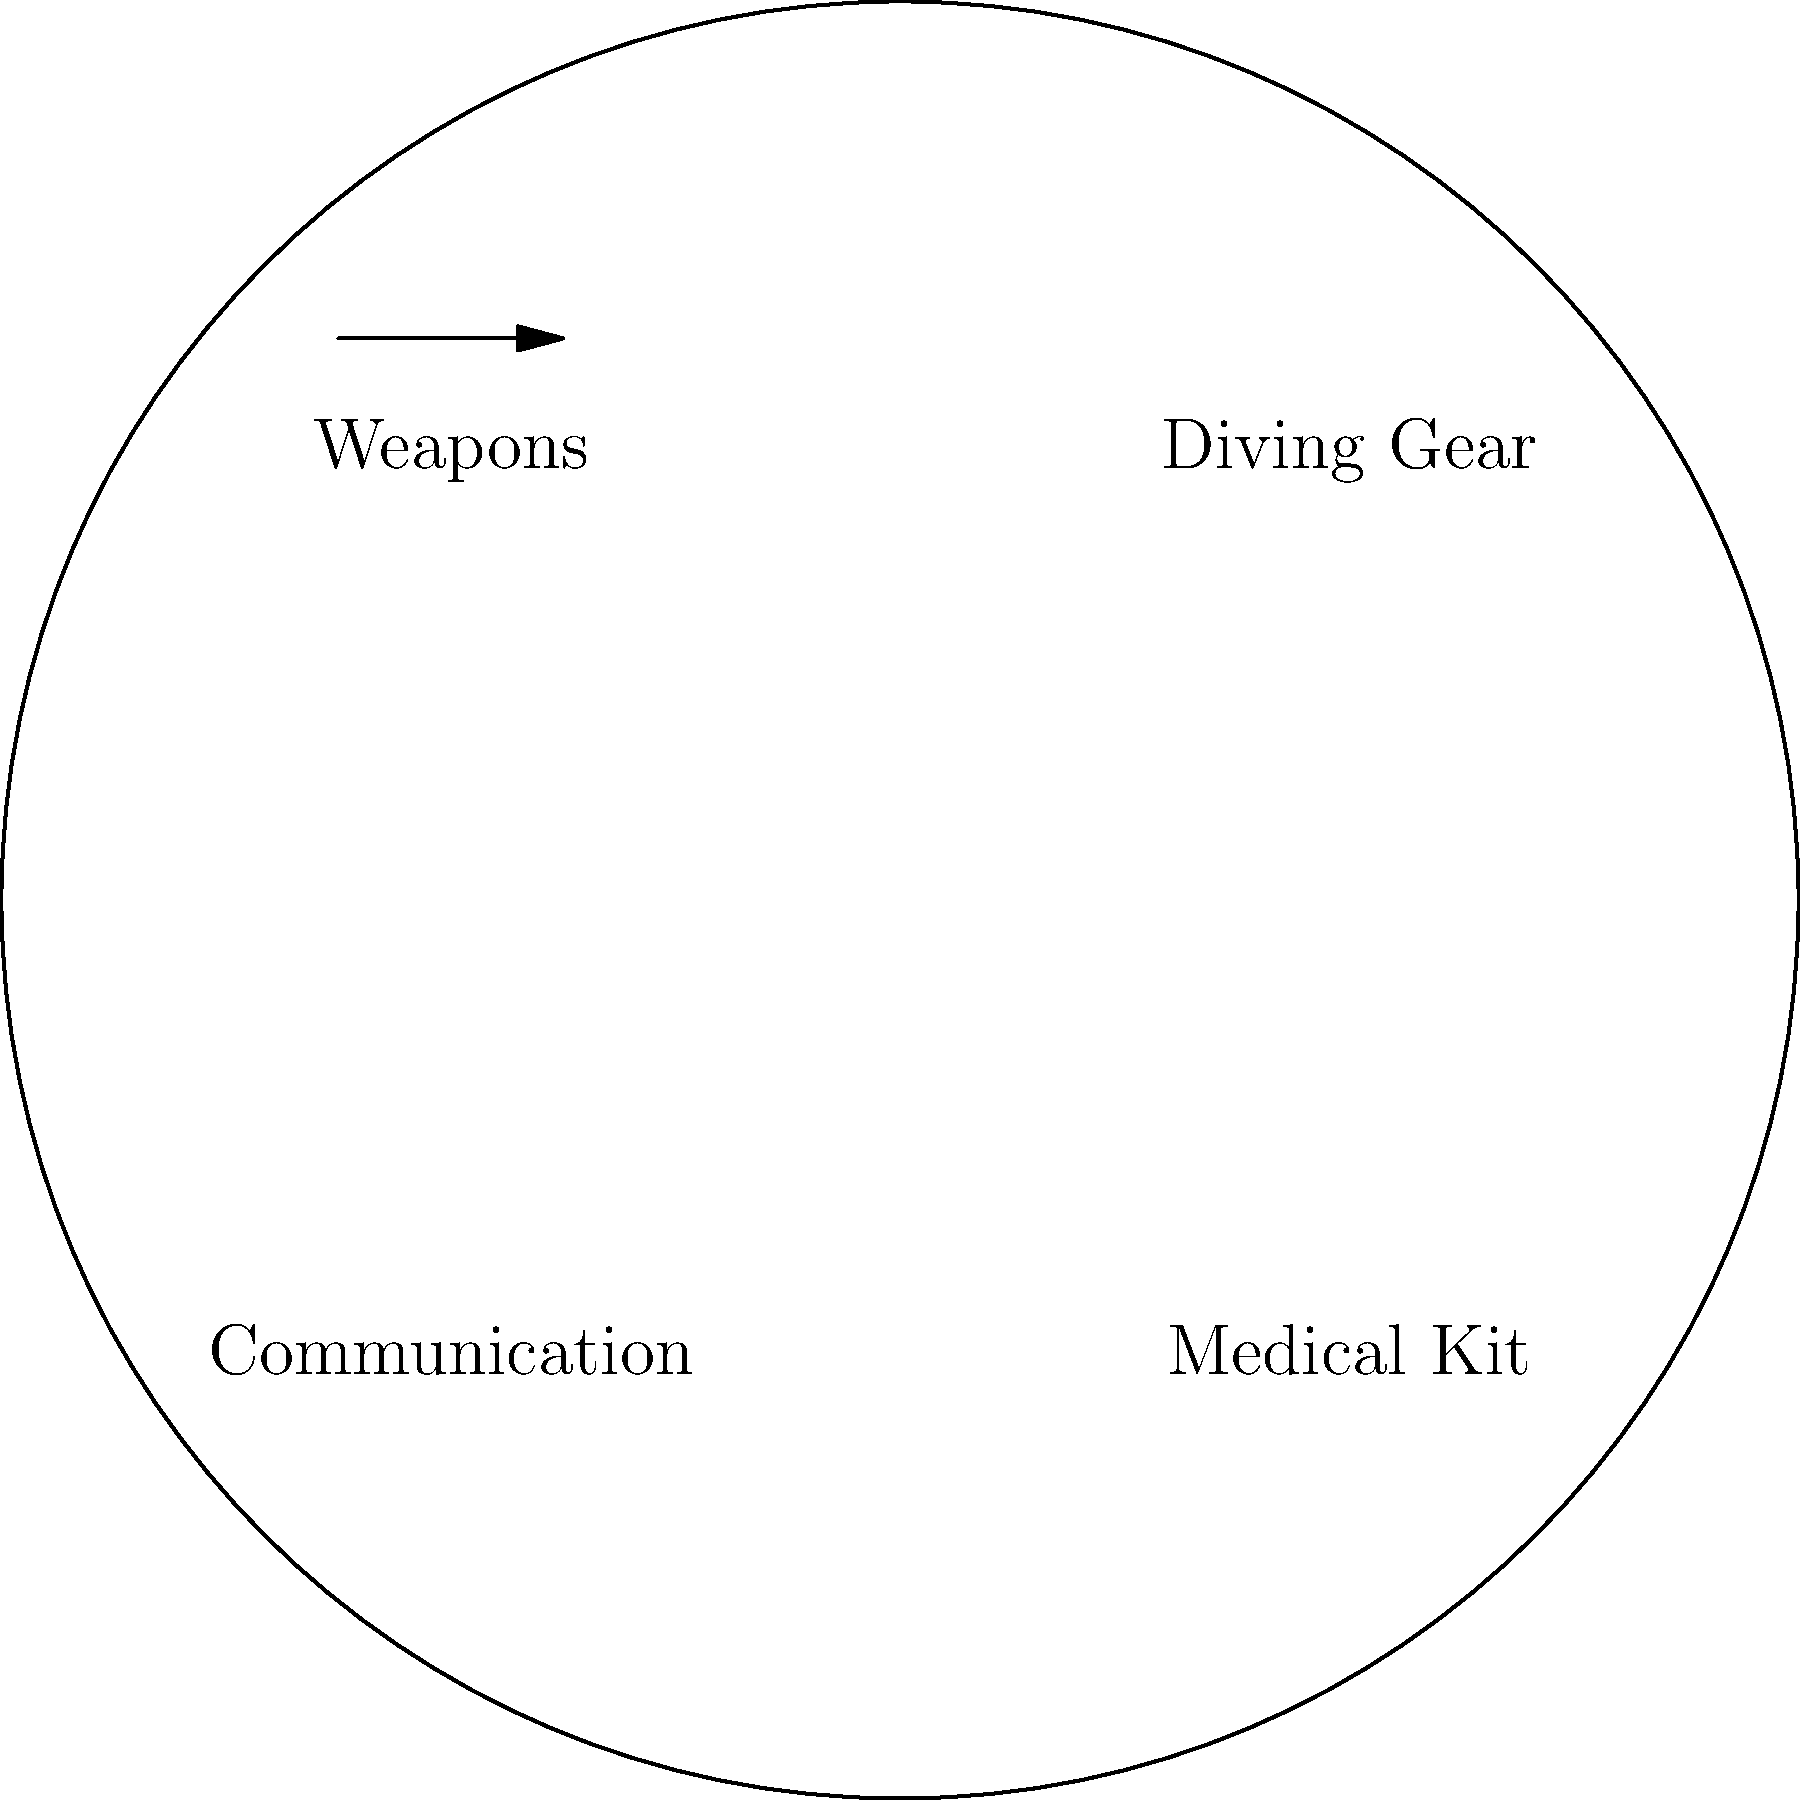Based on the diagram, which of the four main categories of Navy SEAL equipment is represented by the blue line? To answer this question, we need to analyze the diagram carefully:

1. The diagram shows four main categories of Navy SEAL equipment: Weapons, Diving Gear, Communication, and Medical Kit.

2. Each category is represented by a different symbol:
   - Weapons: An arrow
   - Diving Gear: A blue line
   - Communication: A diagonal line
   - Medical Kit: A red circle

3. The question specifically asks about the equipment represented by the blue line.

4. Looking at the diagram, we can see that the blue line is associated with the "Diving Gear" label.

Therefore, the category of Navy SEAL equipment represented by the blue line is Diving Gear.
Answer: Diving Gear 